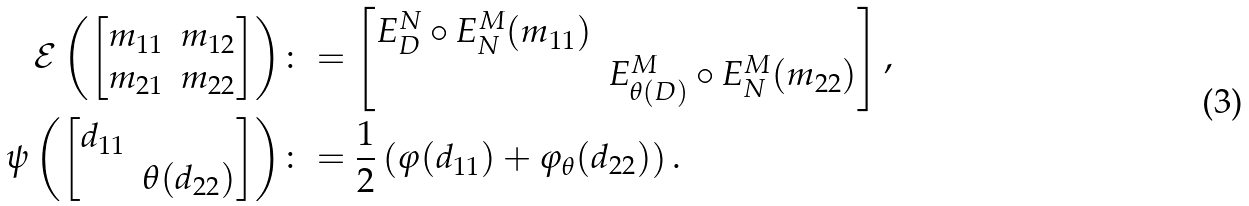Convert formula to latex. <formula><loc_0><loc_0><loc_500><loc_500>\mathcal { E } \left ( \begin{bmatrix} m _ { 1 1 } & m _ { 1 2 } \\ m _ { 2 1 } & m _ { 2 2 } \end{bmatrix} \right ) & \colon = \begin{bmatrix} E _ { D } ^ { N } \circ E _ { N } ^ { M } ( m _ { 1 1 } ) & \\ & E _ { \theta ( D ) } ^ { M } \circ E _ { N } ^ { M } ( m _ { 2 2 } ) \end{bmatrix} , \\ \psi \left ( \begin{bmatrix} d _ { 1 1 } & \\ & \theta ( d _ { 2 2 } ) \end{bmatrix} \right ) & \colon = \frac { 1 } { 2 } \left ( \varphi ( d _ { 1 1 } ) + \varphi _ { \theta } ( d _ { 2 2 } ) \right ) .</formula> 